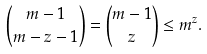Convert formula to latex. <formula><loc_0><loc_0><loc_500><loc_500>\binom { m - 1 } { m - z - 1 } = \binom { m - 1 } { z } \leq m ^ { z } .</formula> 